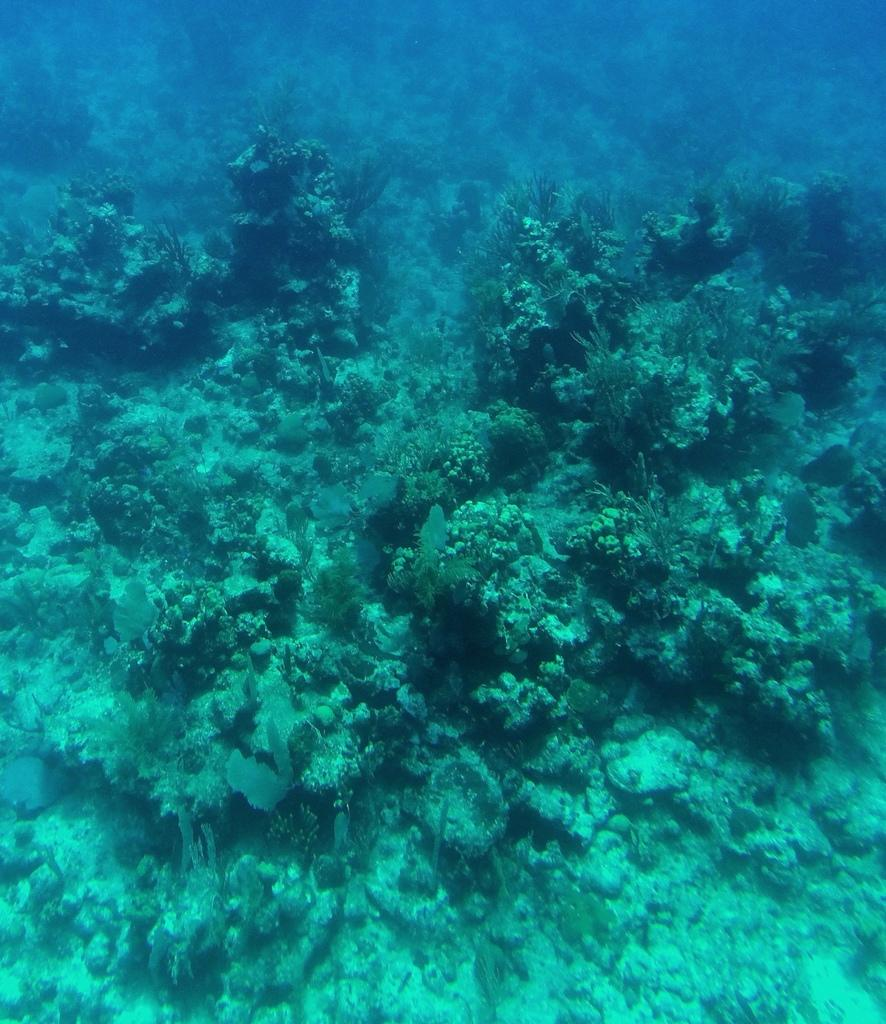What is the focus of the image? The image is zoomed in, so the focus is on a specific area or subject. What can be seen in the foreground of the image? There are plants in the foreground of the image. Where are the plants located? The plants are in a water body. What can be seen in the background of the image? There is a water body visible in the background of the image. What type of dress is hanging on the tree in the image? There is no dress present in the image; it features plants in a water body. What is the afterthought of the person who took the image? We cannot determine the afterthought of the person who took the image based on the information provided. 